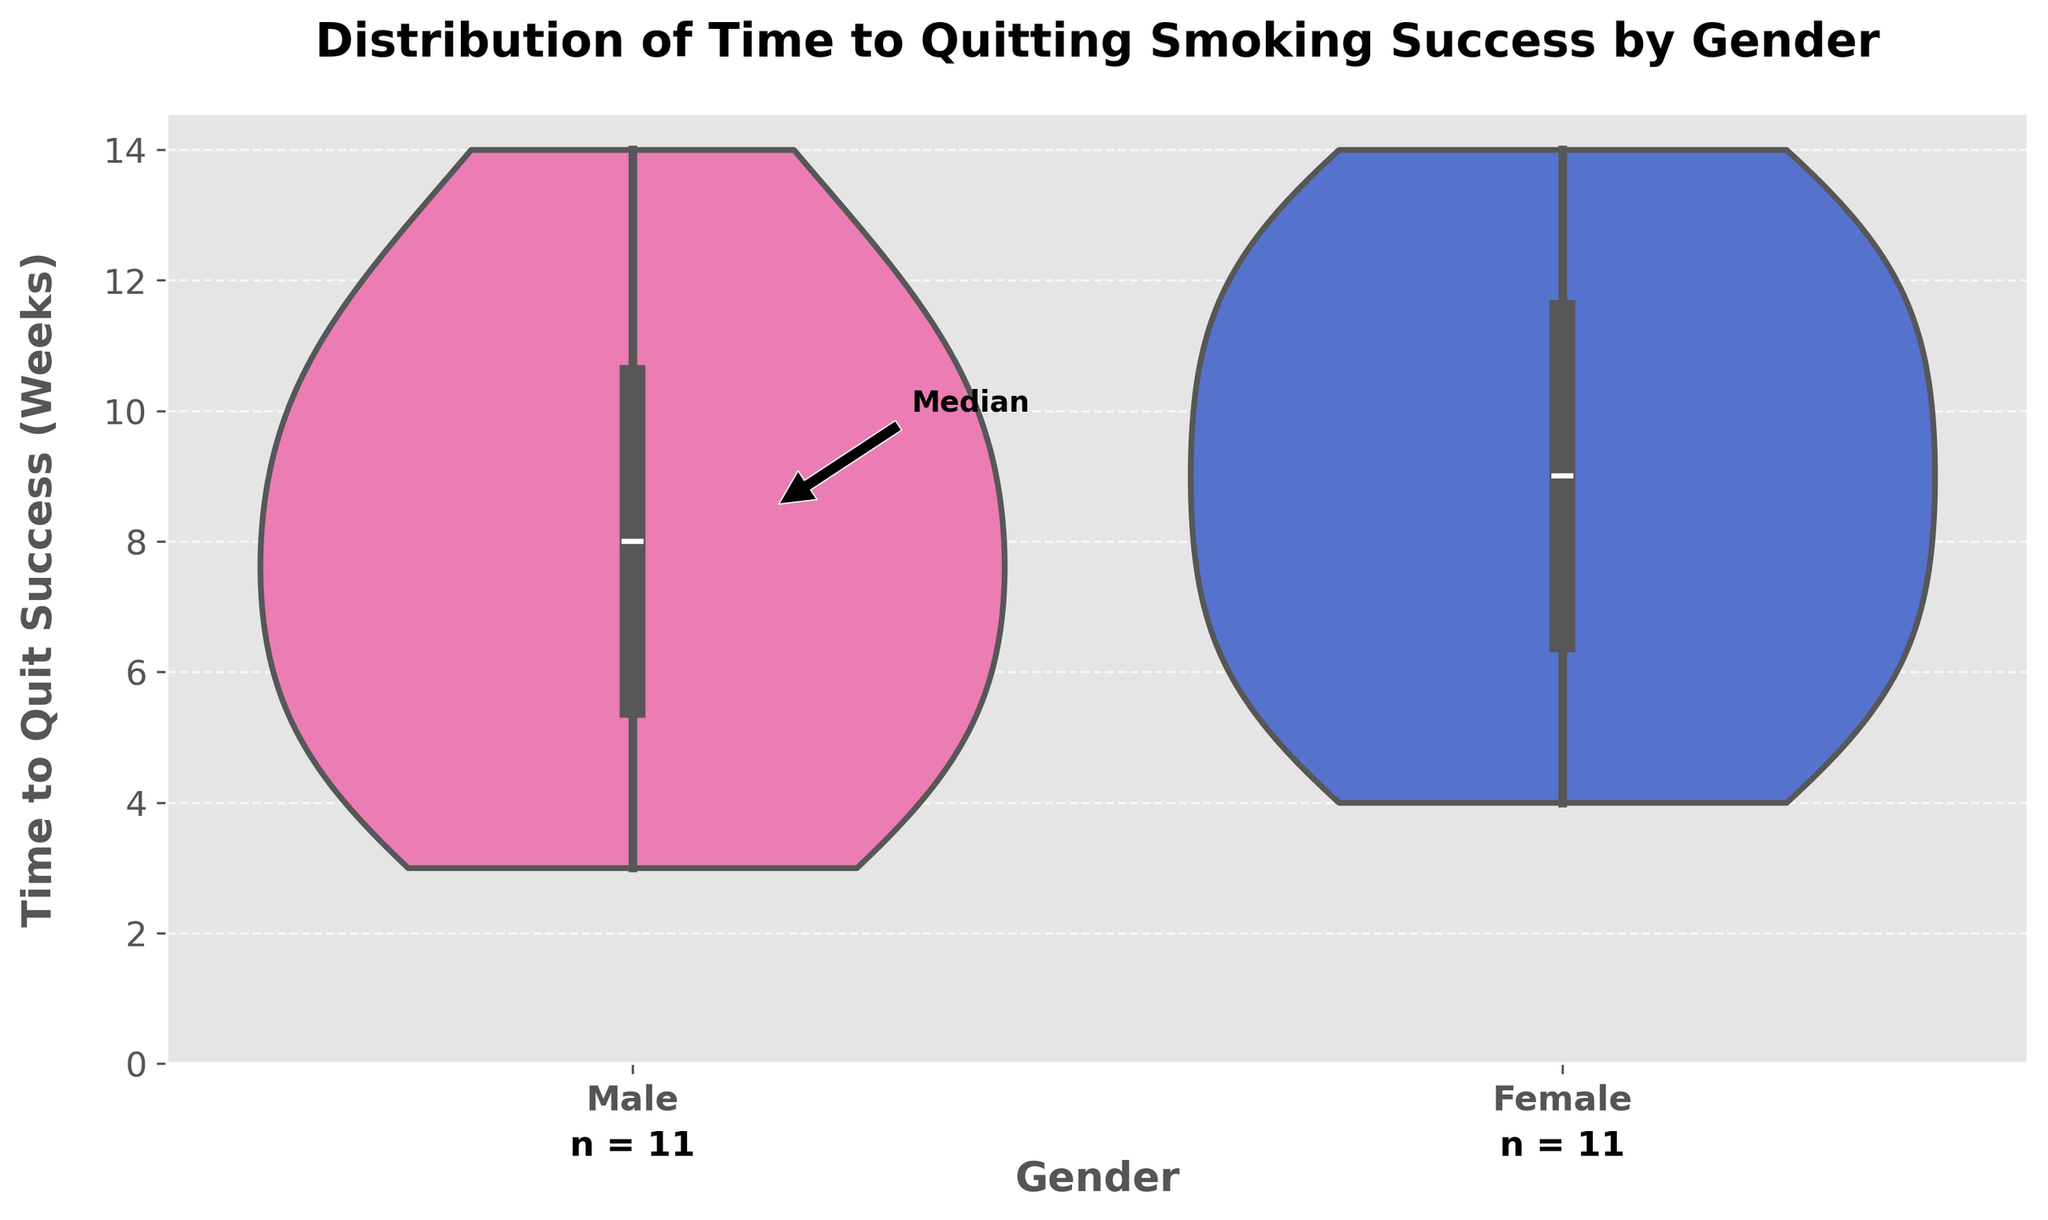What's the title of the figure? The title of the figure is located at the top and is designed to give an overview of what the chart is about. It usually includes the subject matter of the data being represented.
Answer: Distribution of Time to Quitting Smoking Success by Gender What are the labels of the axes? The x-axis label is often shown at the bottom of the chart, indicating what categories or groups are being compared. The y-axis label runs along the vertical side, showing what values are being measured.
Answer: Gender (x-axis), Time to Quit Success (Weeks) (y-axis) How many males are included in the data? The number of male data points is indicated below the plot, annotated with "n =". For males, this is shown at the base of the male violin plot.
Answer: 11 What is the range of Time to Quit Success for females? The range can be determined by looking at the spread of the violin plot and the box plot placeholders. The minimum and maximum values for females span from the lowest to the highest points in the plot.
Answer: 4 to 14 weeks What is the median time to quit smoking for males? The median value is shown by the thick line inside the box plot within the violin plot. For males, this line crosses the appropriate week value.
Answer: 7 weeks Who has a wider distribution of times to quit smoking, males or females? A wider distribution indicates more variability in the data points. This is observed by comparing the width of the two violin plots.
Answer: Females Which gender had the shortest time to quit smoking? The shortest time is indicated by the lowest data point in the violin plots.
Answer: Males (3 weeks) What is the interquartile range (IQR) for females? The interquartile range is found by subtracting the lower quartile value from the upper quartile value in the box plot within the violin plot.
Answer: 5 weeks (10 - 5) How do the maximum values of time to quit smoking compare between genders? The maximum values are represented by the topmost points in each violin plot. Comparing the maximum points for both genders will give the answer.
Answer: Both are equal (14 weeks each) Considering the plots, which gender seems to have more consistency in their quitting times? Consistency can be assessed by the concentration and overall shape of the violin plots along with the box plot spans. The gender with the narrower range is more consistent.
Answer: Males 